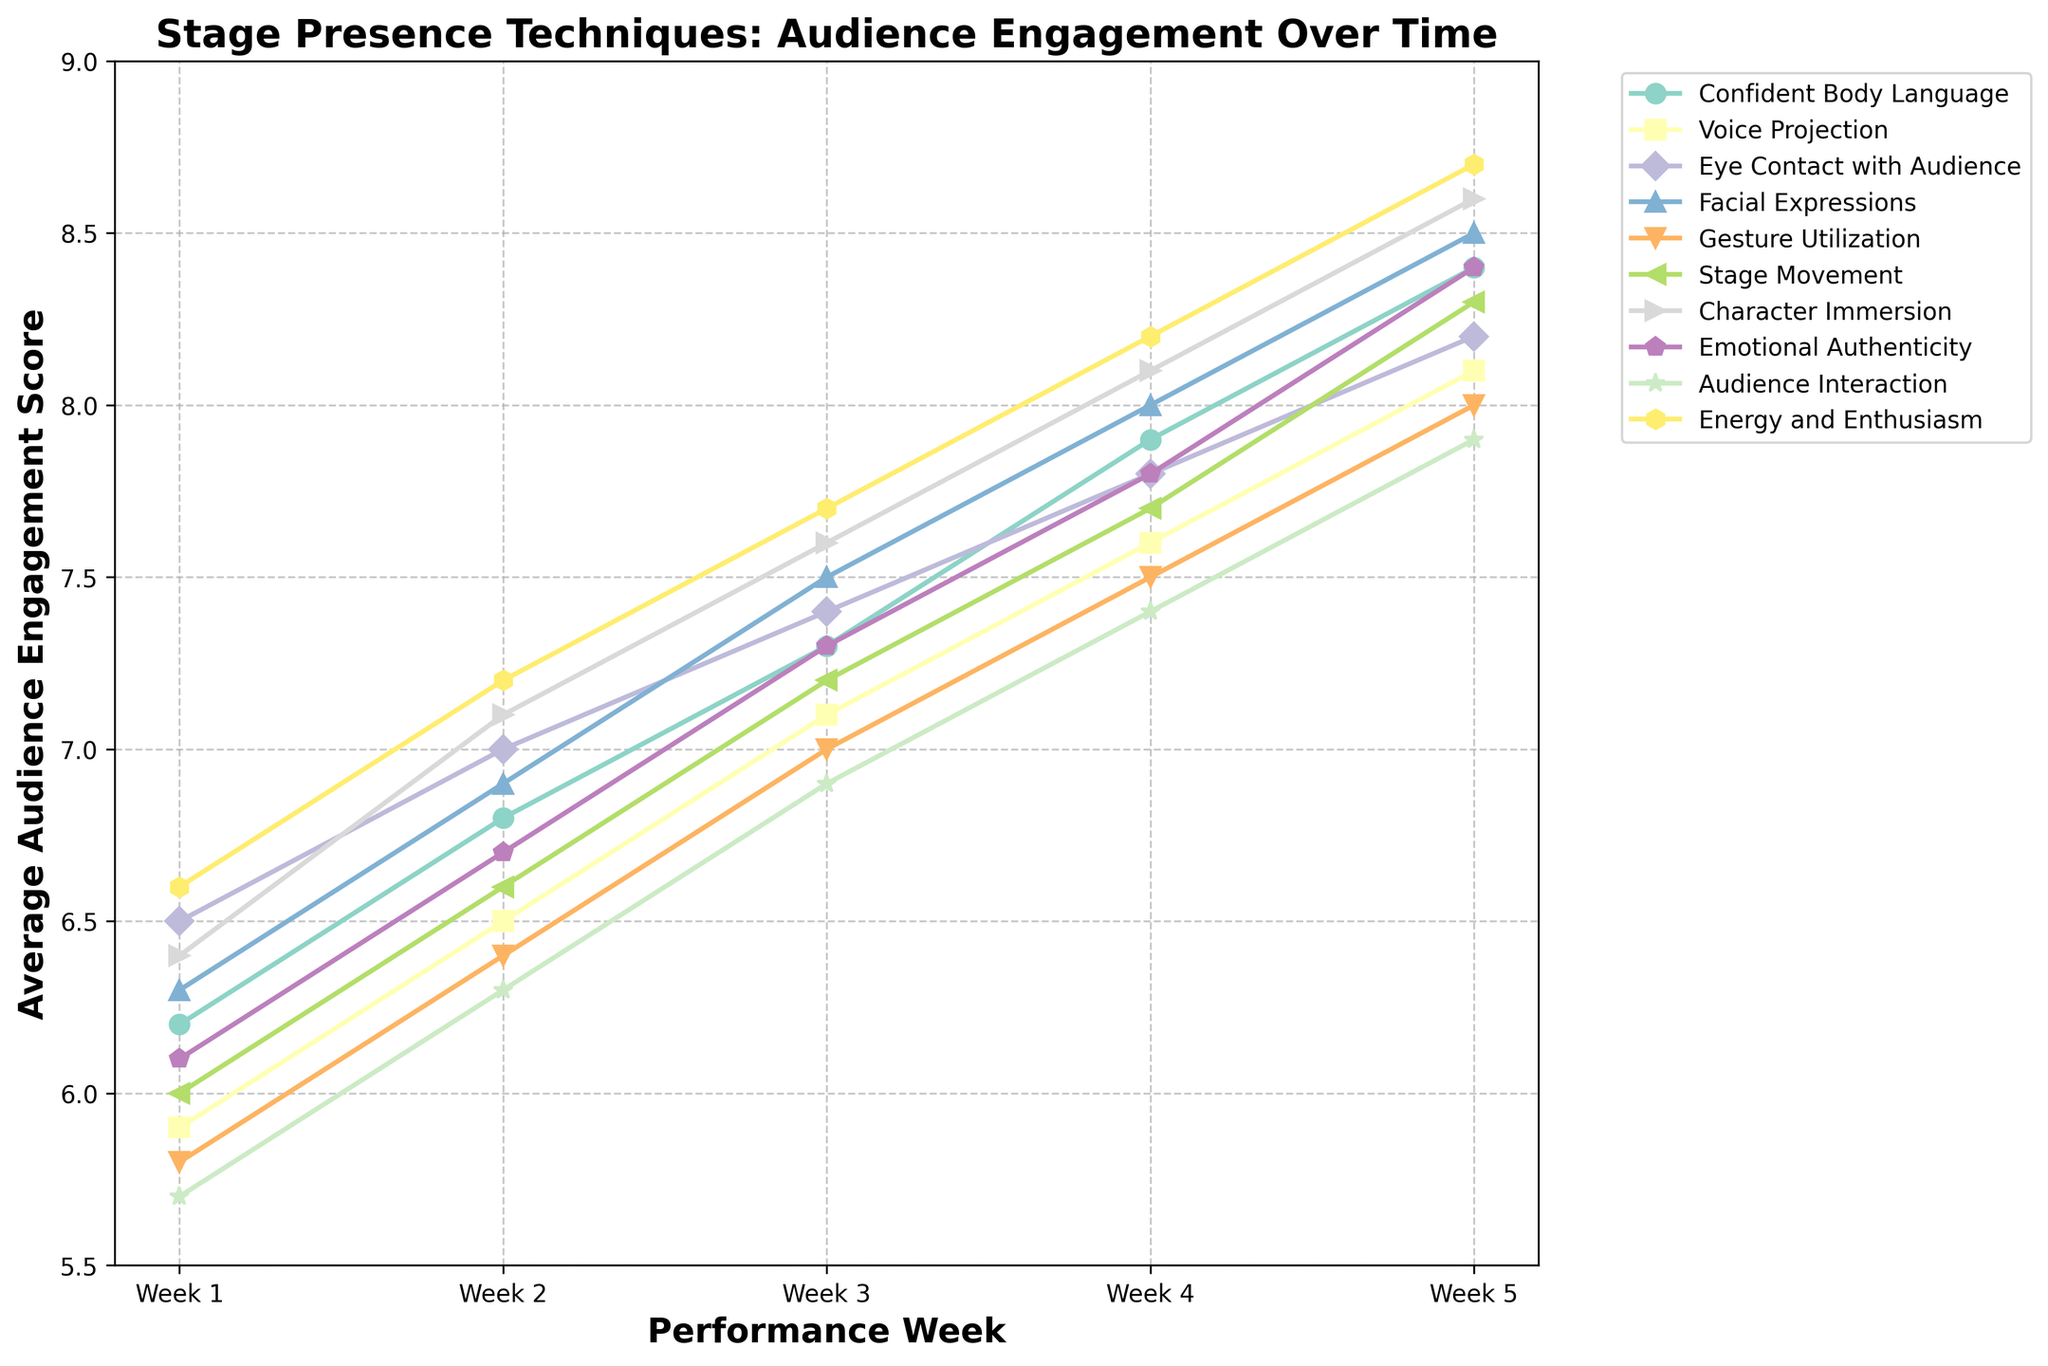Which technique has the highest average audience engagement score in Week 5? Look at the y-values for Week 5 and identify the highest value for any technique. "Energy and Enthusiasm" has a score of 8.7, which is the highest.
Answer: Energy and Enthusiasm Which techniques show an average audience engagement score of 8.4 in Week 5? Check all the y-values in Week 5 and find which ones are 8.4. Both "Confident Body Language" and "Emotional Authenticity" have a score of 8.4.
Answer: Confident Body Language, Emotional Authenticity How does the engagement score change for "Voice Projection" from Week 1 to Week 5? Subtract the Week 1 engagement score of "Voice Projection" from the Week 5 score. The change is 8.1 - 5.9 = 2.2.
Answer: 2.2 Compare the engagement scores of "Eye Contact with Audience" and "Stage Movement" in Week 3. Which one is higher? Check the y-values for both techniques in Week 3. "Eye Contact with Audience" has a score of 7.4 while "Stage Movement" has a score of 7.2, making "Eye Contact with Audience" higher.
Answer: Eye Contact with Audience What is the average engagement score of "Gesture Utilization" over all weeks? Add up the engagement scores of "Gesture Utilization" across Weeks 1 to 5 and divide by 5: (5.8 + 6.4 + 7.0 + 7.5 + 8.0) / 5 = 6.94.
Answer: 6.94 Which technique has the largest increase in audience engagement from Week 2 to Week 3? Calculate the difference between Week 2 and Week 3 values for all techniques. "Facial Expressions" has an increase from 6.9 to 7.5, a difference of 0.6, which is the largest.
Answer: Facial Expressions Which techniques have engagement scores exceeding 8.0 in Week 5? Check all the y-values in Week 5 and identify scores higher than 8.0. They are "Confident Body Language," "Voice Projection," "Eye Contact with Audience," "Facial Expressions," "Stage Movement," "Character Immersion," "Emotional Authenticity," "Audience Interaction," and "Energy and Enthusiasm."
Answer: Confident Body Language, Voice Projection, Eye Contact with Audience, Facial Expressions, Stage Movement, Character Immersion, Emotional Authenticity, Audience Interaction, Energy and Enthusiasm What is the engagement score range for "Character Immersion" over the five weeks? Identify the minimum and maximum engagement scores for "Character Immersion" across Weeks 1 to 5. The range is from 6.4 to 8.6.
Answer: 6.4 to 8.6 Compare the trends for "Confident Body Language" and "Audience Interaction." How do they differ by Week 4? "Confident Body Language" consistently increases, while "Audience Interaction" has a similar pattern but the increase is slightly less steep. By Week 4, "Confident Body Language" reaches 7.9 compared to "Audience Interaction"'s 7.4.
Answer: Confident Body Language shows a steeper and higher increase Which two techniques reached the same engagement score in Week 3 but vary in Week 5? Examine the Week 3 scores and identify any that are the same. "Emotional Authenticity" and "Confident Body Language" both have a score of 7.3 in Week 3 but have different scores in Week 5.
Answer: Emotional Authenticity, Confident Body Language 